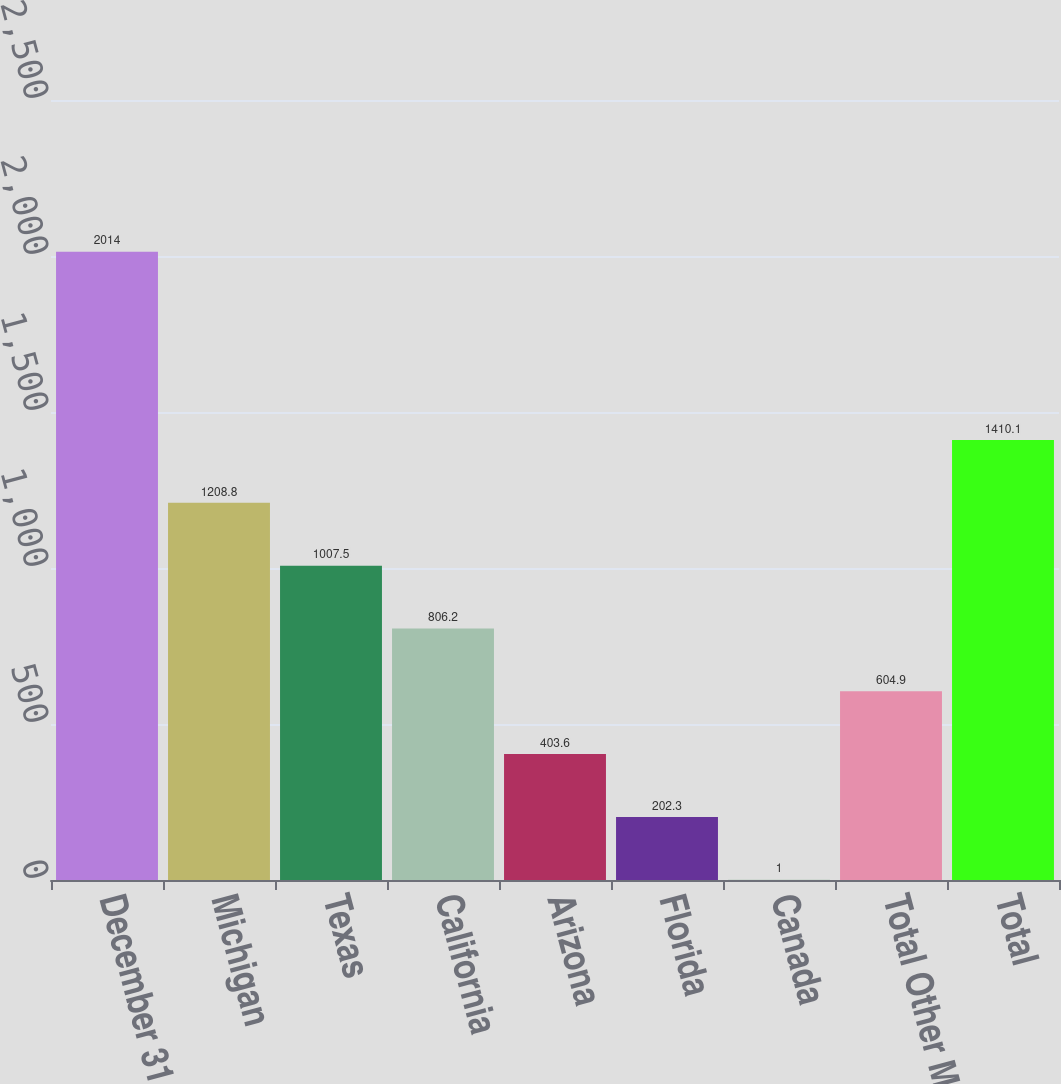Convert chart to OTSL. <chart><loc_0><loc_0><loc_500><loc_500><bar_chart><fcel>December 31<fcel>Michigan<fcel>Texas<fcel>California<fcel>Arizona<fcel>Florida<fcel>Canada<fcel>Total Other Markets<fcel>Total<nl><fcel>2014<fcel>1208.8<fcel>1007.5<fcel>806.2<fcel>403.6<fcel>202.3<fcel>1<fcel>604.9<fcel>1410.1<nl></chart> 